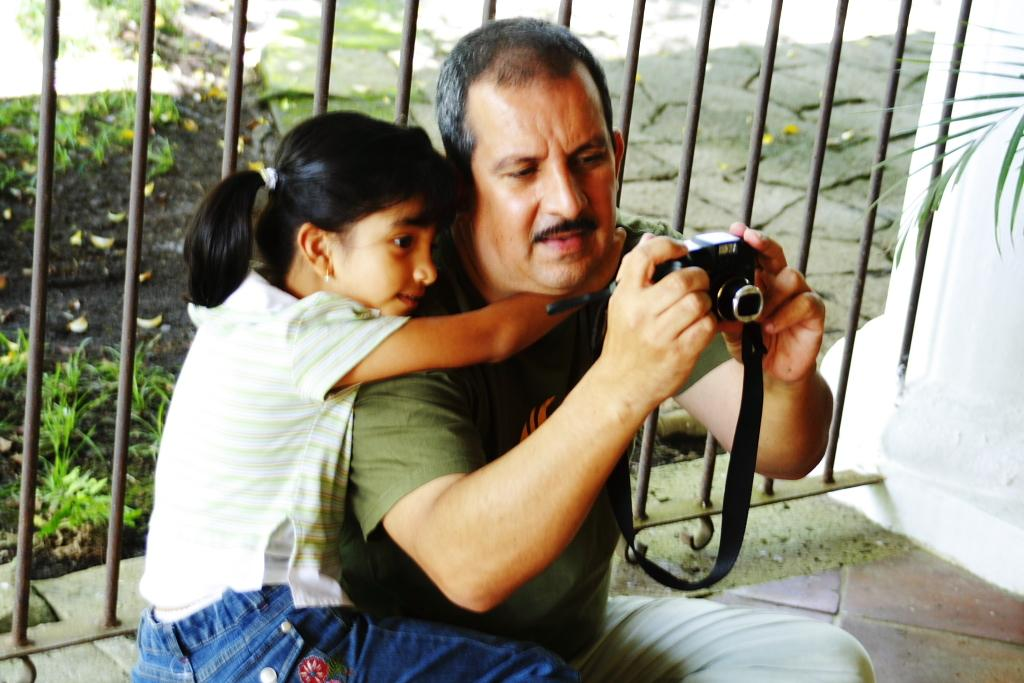What is the main subject of the image? The main subject of the image is a child. What is the child doing in the image? The child is holding a man and looking into the camera. What can be seen in the background of the image? There is a fence and grass in the background of the image. How far away is the hydrant from the child in the image? There is no hydrant present in the image, so it cannot be determined how far away it would be from the child. 